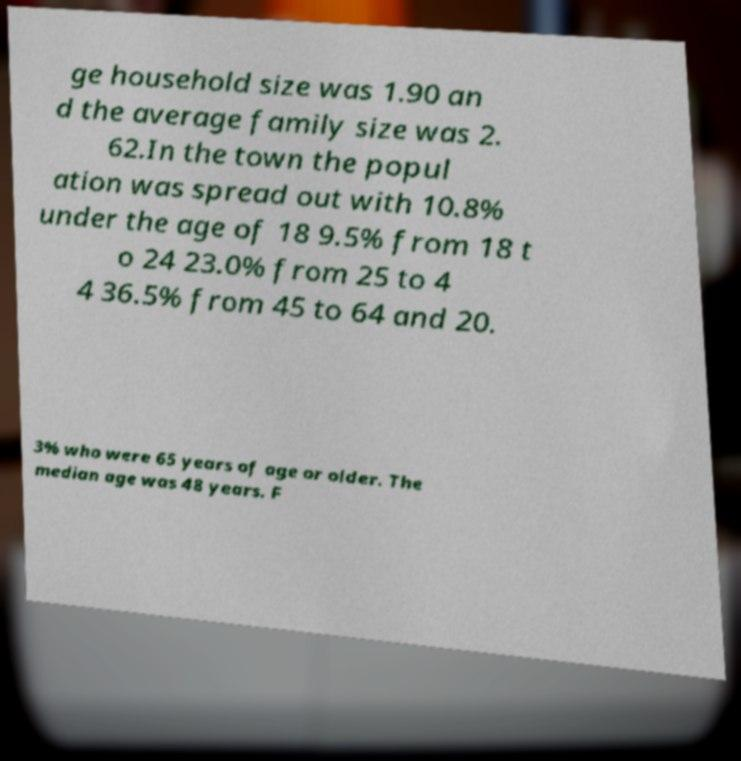Can you read and provide the text displayed in the image?This photo seems to have some interesting text. Can you extract and type it out for me? ge household size was 1.90 an d the average family size was 2. 62.In the town the popul ation was spread out with 10.8% under the age of 18 9.5% from 18 t o 24 23.0% from 25 to 4 4 36.5% from 45 to 64 and 20. 3% who were 65 years of age or older. The median age was 48 years. F 